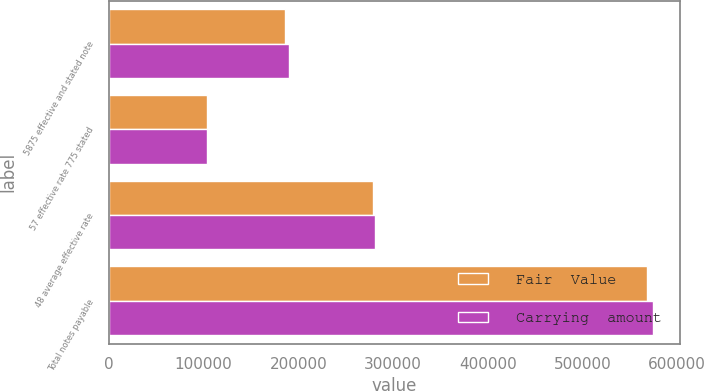Convert chart. <chart><loc_0><loc_0><loc_500><loc_500><stacked_bar_chart><ecel><fcel>5875 effective and stated note<fcel>57 effective rate 775 stated<fcel>48 average effective rate<fcel>Total notes payable<nl><fcel>Fair  Value<fcel>186460<fcel>103532<fcel>278425<fcel>568417<nl><fcel>Carrying  amount<fcel>190012<fcel>103553<fcel>280854<fcel>574419<nl></chart> 